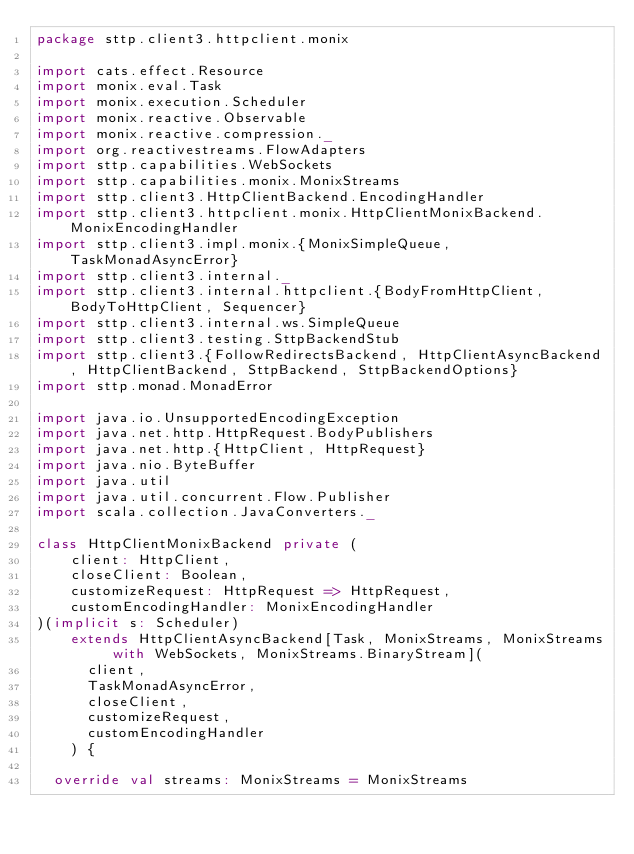Convert code to text. <code><loc_0><loc_0><loc_500><loc_500><_Scala_>package sttp.client3.httpclient.monix

import cats.effect.Resource
import monix.eval.Task
import monix.execution.Scheduler
import monix.reactive.Observable
import monix.reactive.compression._
import org.reactivestreams.FlowAdapters
import sttp.capabilities.WebSockets
import sttp.capabilities.monix.MonixStreams
import sttp.client3.HttpClientBackend.EncodingHandler
import sttp.client3.httpclient.monix.HttpClientMonixBackend.MonixEncodingHandler
import sttp.client3.impl.monix.{MonixSimpleQueue, TaskMonadAsyncError}
import sttp.client3.internal._
import sttp.client3.internal.httpclient.{BodyFromHttpClient, BodyToHttpClient, Sequencer}
import sttp.client3.internal.ws.SimpleQueue
import sttp.client3.testing.SttpBackendStub
import sttp.client3.{FollowRedirectsBackend, HttpClientAsyncBackend, HttpClientBackend, SttpBackend, SttpBackendOptions}
import sttp.monad.MonadError

import java.io.UnsupportedEncodingException
import java.net.http.HttpRequest.BodyPublishers
import java.net.http.{HttpClient, HttpRequest}
import java.nio.ByteBuffer
import java.util
import java.util.concurrent.Flow.Publisher
import scala.collection.JavaConverters._

class HttpClientMonixBackend private (
    client: HttpClient,
    closeClient: Boolean,
    customizeRequest: HttpRequest => HttpRequest,
    customEncodingHandler: MonixEncodingHandler
)(implicit s: Scheduler)
    extends HttpClientAsyncBackend[Task, MonixStreams, MonixStreams with WebSockets, MonixStreams.BinaryStream](
      client,
      TaskMonadAsyncError,
      closeClient,
      customizeRequest,
      customEncodingHandler
    ) {

  override val streams: MonixStreams = MonixStreams
</code> 